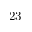Convert formula to latex. <formula><loc_0><loc_0><loc_500><loc_500>2 3</formula> 